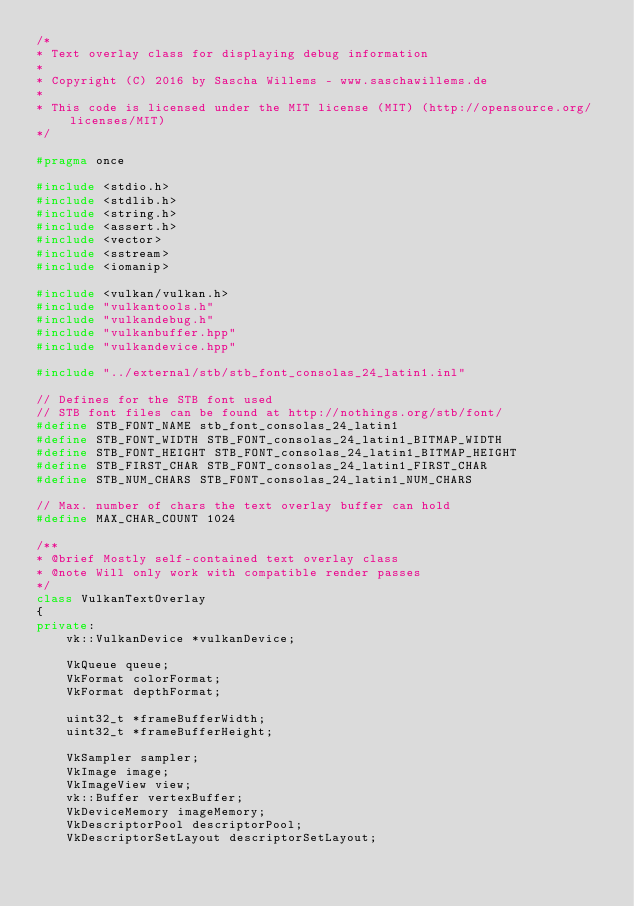<code> <loc_0><loc_0><loc_500><loc_500><_C++_>/*
* Text overlay class for displaying debug information
*
* Copyright (C) 2016 by Sascha Willems - www.saschawillems.de
*
* This code is licensed under the MIT license (MIT) (http://opensource.org/licenses/MIT)
*/

#pragma once

#include <stdio.h>
#include <stdlib.h>
#include <string.h>
#include <assert.h>
#include <vector>
#include <sstream>
#include <iomanip>

#include <vulkan/vulkan.h>
#include "vulkantools.h"
#include "vulkandebug.h"
#include "vulkanbuffer.hpp"
#include "vulkandevice.hpp"

#include "../external/stb/stb_font_consolas_24_latin1.inl"

// Defines for the STB font used
// STB font files can be found at http://nothings.org/stb/font/
#define STB_FONT_NAME stb_font_consolas_24_latin1
#define STB_FONT_WIDTH STB_FONT_consolas_24_latin1_BITMAP_WIDTH
#define STB_FONT_HEIGHT STB_FONT_consolas_24_latin1_BITMAP_HEIGHT 
#define STB_FIRST_CHAR STB_FONT_consolas_24_latin1_FIRST_CHAR
#define STB_NUM_CHARS STB_FONT_consolas_24_latin1_NUM_CHARS

// Max. number of chars the text overlay buffer can hold
#define MAX_CHAR_COUNT 1024

/**
* @brief Mostly self-contained text overlay class
* @note Will only work with compatible render passes
*/ 
class VulkanTextOverlay
{
private:
	vk::VulkanDevice *vulkanDevice;

	VkQueue queue;
	VkFormat colorFormat;
	VkFormat depthFormat;

	uint32_t *frameBufferWidth;
	uint32_t *frameBufferHeight;

	VkSampler sampler;
	VkImage image;
	VkImageView view;
	vk::Buffer vertexBuffer;
	VkDeviceMemory imageMemory;
	VkDescriptorPool descriptorPool;
	VkDescriptorSetLayout descriptorSetLayout;</code> 